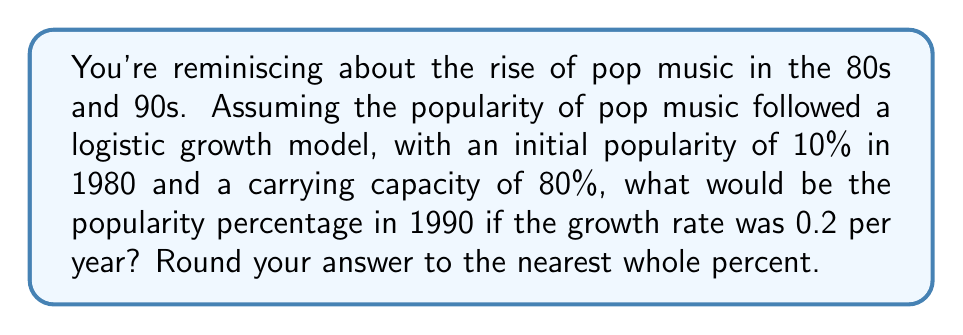Can you solve this math problem? Let's approach this step-by-step using the logistic growth equation:

1) The logistic growth equation is:

   $$P(t) = \frac{K}{1 + (\frac{K}{P_0} - 1)e^{-rt}}$$

   Where:
   $P(t)$ is the popularity at time $t$
   $K$ is the carrying capacity
   $P_0$ is the initial popularity
   $r$ is the growth rate
   $t$ is the time in years

2) We're given:
   $K = 80\%$ = 0.8
   $P_0 = 10\%$ = 0.1
   $r = 0.2$
   $t = 10$ years (from 1980 to 1990)

3) Let's substitute these values into the equation:

   $$P(10) = \frac{0.8}{1 + (\frac{0.8}{0.1} - 1)e^{-0.2(10)}}$$

4) Simplify the fraction inside the parentheses:

   $$P(10) = \frac{0.8}{1 + (8 - 1)e^{-2}}$$

5) Calculate $e^{-2}$:

   $$P(10) = \frac{0.8}{1 + 7 \cdot 0.1353}$$

6) Multiply:

   $$P(10) = \frac{0.8}{1 + 0.9471}$$

7) Add in the denominator:

   $$P(10) = \frac{0.8}{1.9471}$$

8) Divide:

   $$P(10) = 0.4109$$

9) Convert to a percentage and round to the nearest whole percent:

   $0.4109 \cdot 100\% \approx 41\%$
Answer: 41% 